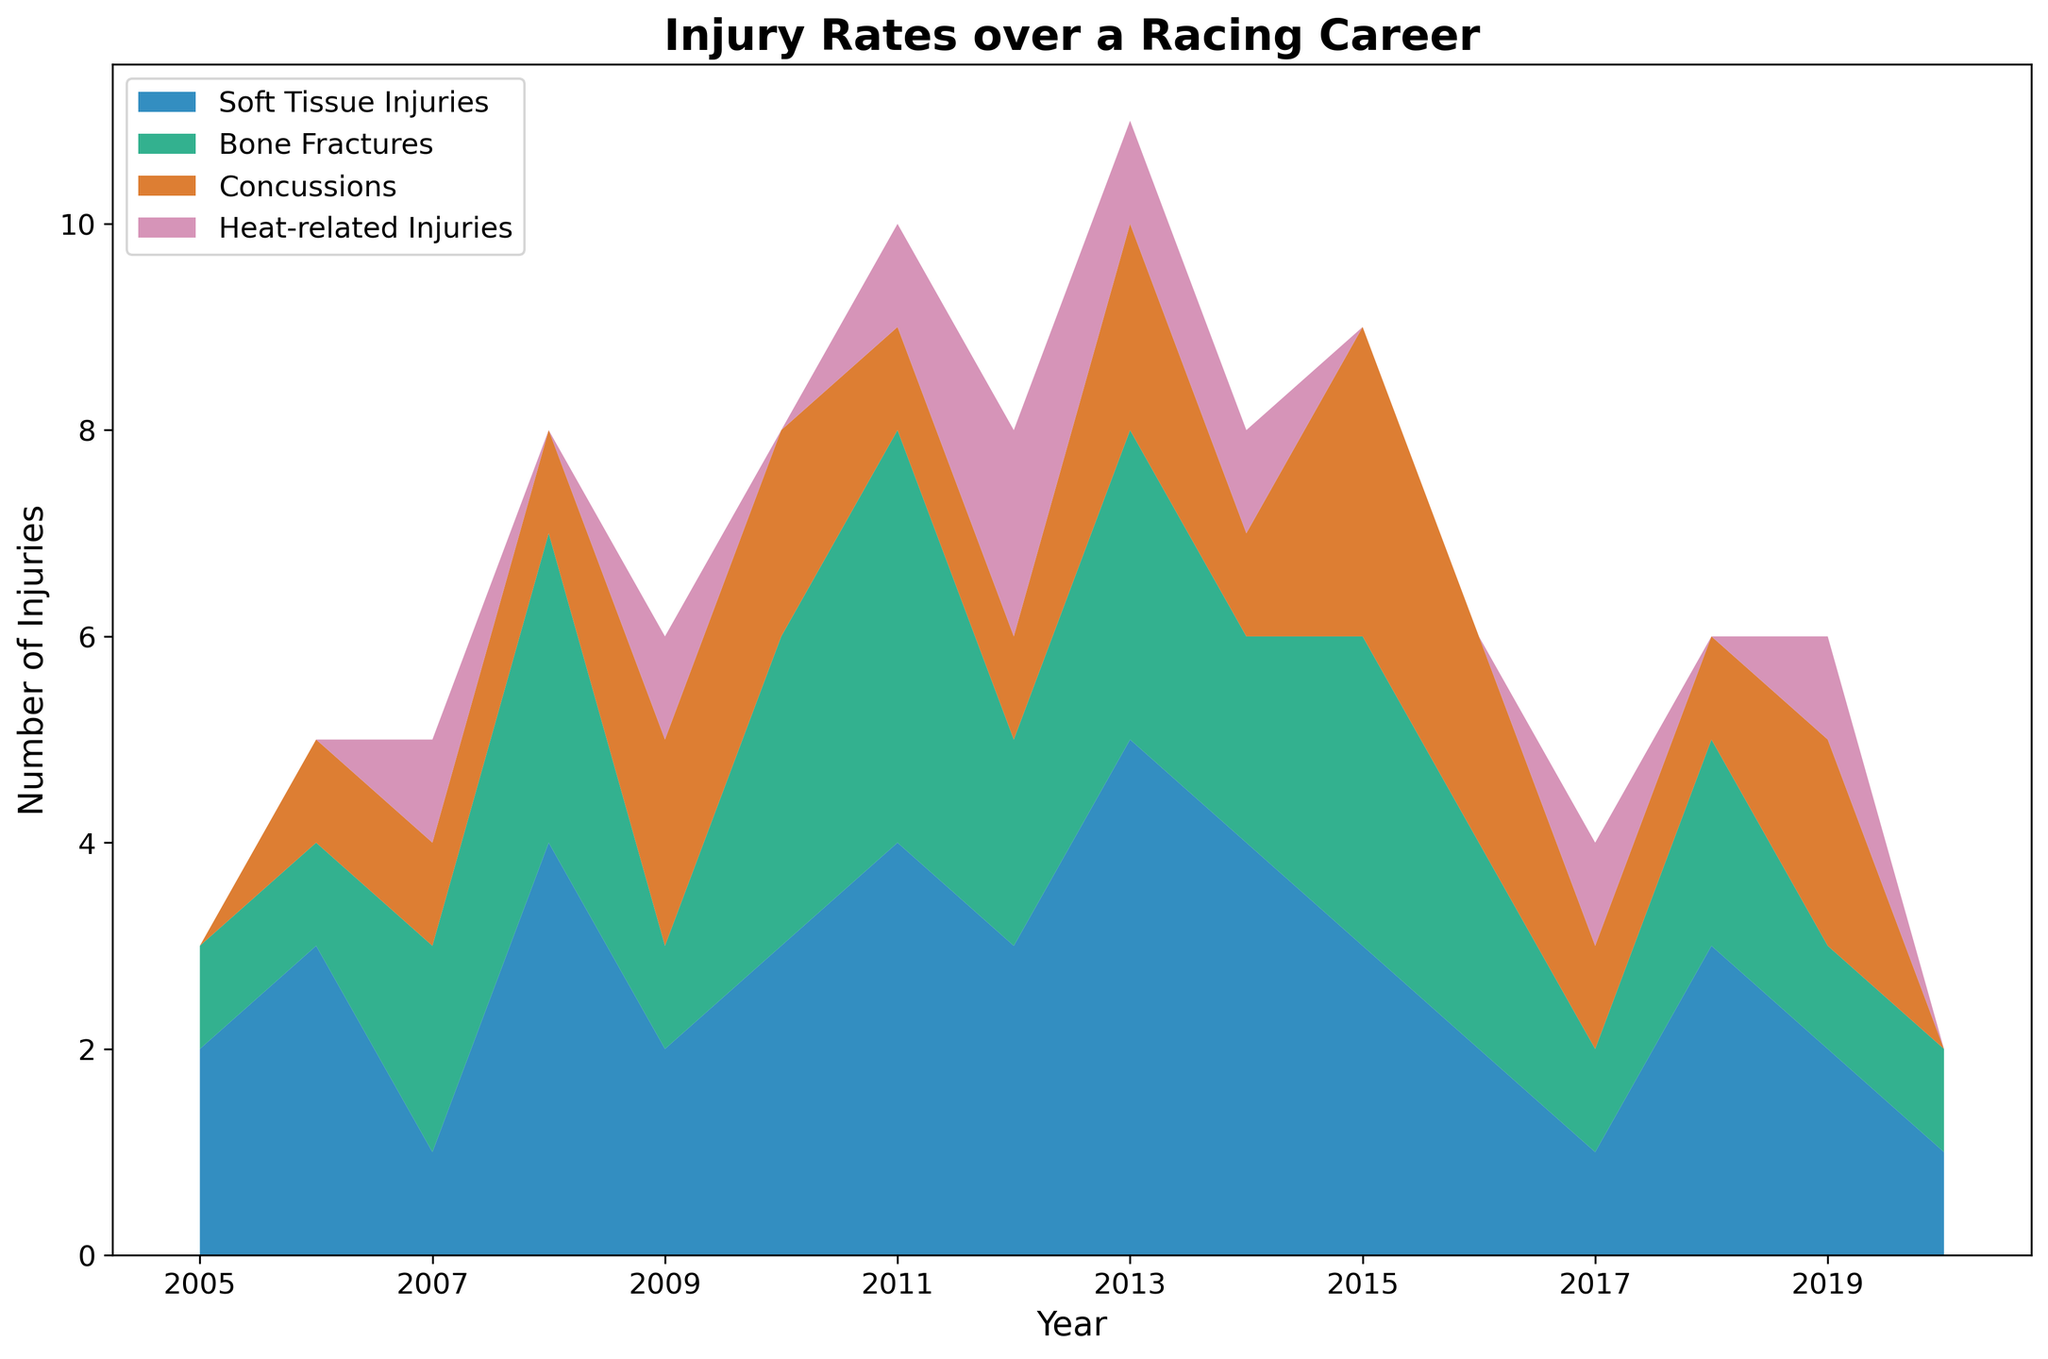What year saw the highest total number of injuries? To determine the year with the highest total number of injuries, we need to sum up the injuries for each year. Upon summing the values for each year, it is clear that 2013 has the highest total number of injuries (5 soft tissue injuries, 3 bone fractures, 2 concussions, 1 heat-related injury), resulting in a total of 11 injuries.
Answer: 2013 How many years had more than 3 concussions? By examining the data series for concussions across all years, we find that no year has more than 3 concussions. The highest number of concussions in any given year is 3, which occurs in 2015.
Answer: 0 Which type of injury was most frequent in 2011? By observing the stacked area for the year 2011, we can see that 'Soft Tissue Injuries' has the largest area for this year, indicating it was the most frequent type of injury in 2011.
Answer: Soft Tissue Injuries Is there a trend in the number of heat-related injuries over the years? From the data, we notice that heat-related injuries occur sporadically. There is no consistent upward or downward trend over the years, with some years having such injuries and others having none.
Answer: No consistent trend What is the total number of injuries in 2010 across all types? To find the total number of injuries in 2010, we sum up all types of injuries for this year: 3 soft tissue injuries, 3 bone fractures, 2 concussions, and 0 heat-related injuries. Therefore, the total is 3 + 3 + 2 + 0 = 8.
Answer: 8 Between 2005 and 2010, which type of injury had the highest overall instances? Summing each type of injury from 2005 to 2010: Soft Tissue Injuries (2+3+1+4+2+3=15), Bone Fractures (1+1+2+3+1+3=11), Concussions (0+1+1+1+2+2=7), Heat-related Injuries (0+0+1+0+1+0=2). Soft Tissue Injuries had the highest overall instances with a total of 15.
Answer: Soft Tissue Injuries In which year did bone fractures and concussions first both occur? By looking at the data for each year, we see that in 2006 both bone fractures and concussions occur (1 each), marking the first instance of both injuries happening in the same year.
Answer: 2006 What is the difference in the number of soft tissue injuries between 2013 and 2014? There were 5 soft tissue injuries in 2013 and 4 in 2014. The difference is 5 - 4 = 1.
Answer: 1 Which year had the lowest number of total injuries? By summing the total number of injuries for each year and comparing, we see that 2020 had the lowest total with 1 soft tissue injury and 1 bone fracture, resulting in a total of 2 injuries.
Answer: 2020 In which year did heat-related injuries peak? Heat-related injuries peaked in 2012 with a total of 2 injuries for that year. This is the maximum number of heat-related injuries in any given year in the dataset.
Answer: 2012 